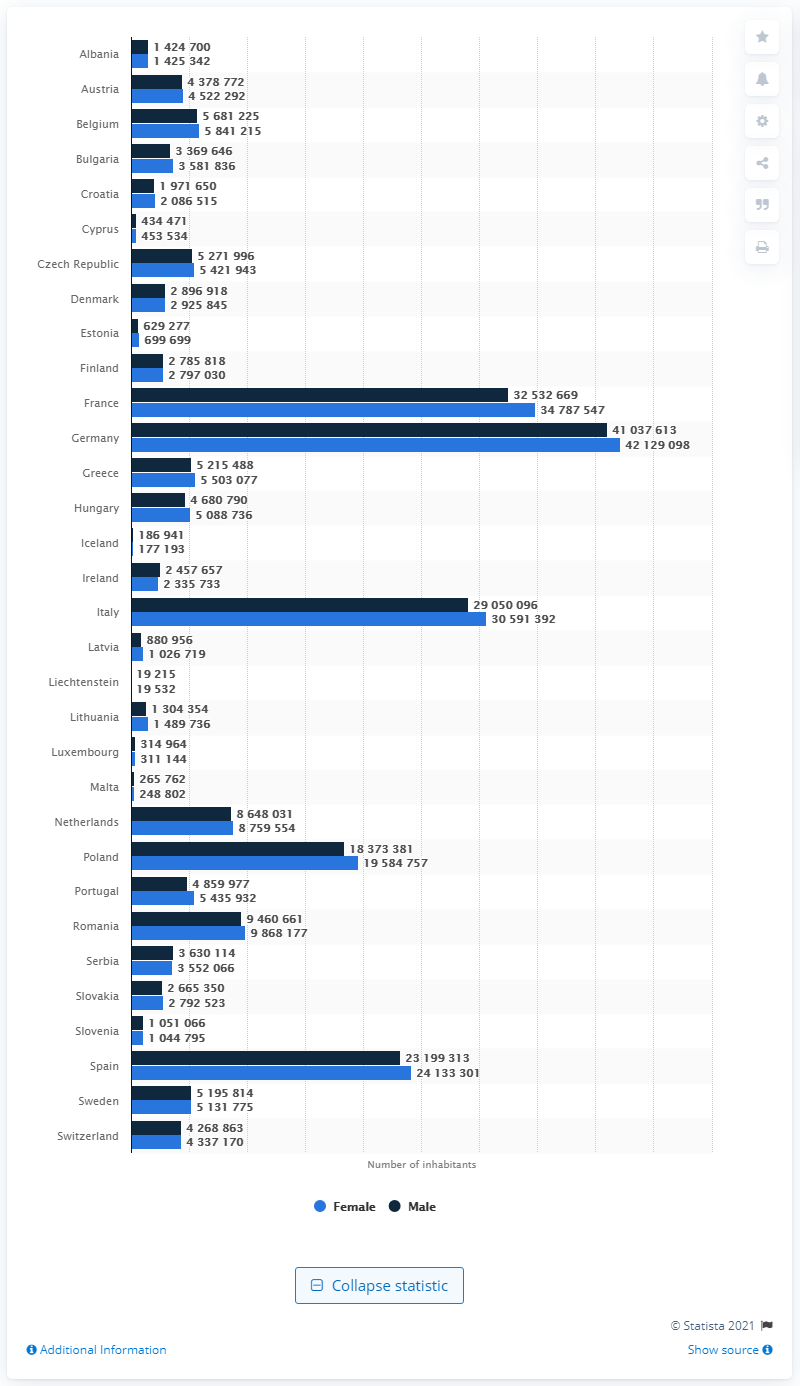Mention a couple of crucial points in this snapshot. The number of males living in Germany is 41037613... According to the most recent statistics, there are 42,129,098 females living in Germany. 